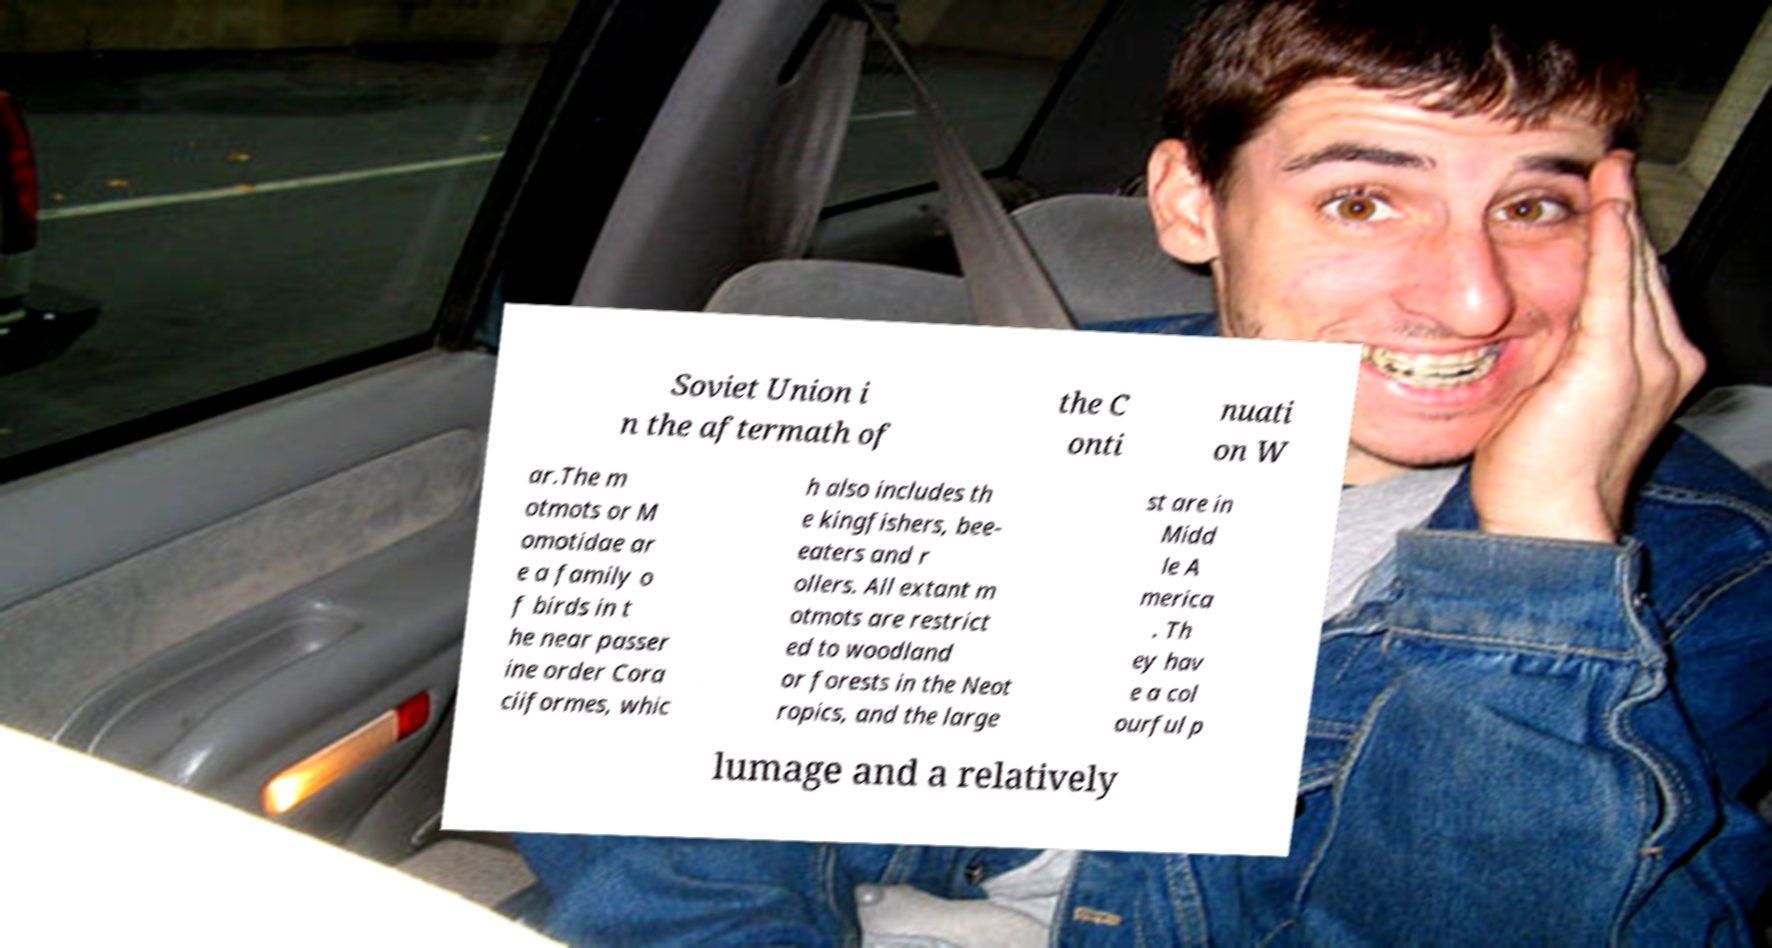Can you read and provide the text displayed in the image?This photo seems to have some interesting text. Can you extract and type it out for me? Soviet Union i n the aftermath of the C onti nuati on W ar.The m otmots or M omotidae ar e a family o f birds in t he near passer ine order Cora ciiformes, whic h also includes th e kingfishers, bee- eaters and r ollers. All extant m otmots are restrict ed to woodland or forests in the Neot ropics, and the large st are in Midd le A merica . Th ey hav e a col ourful p lumage and a relatively 